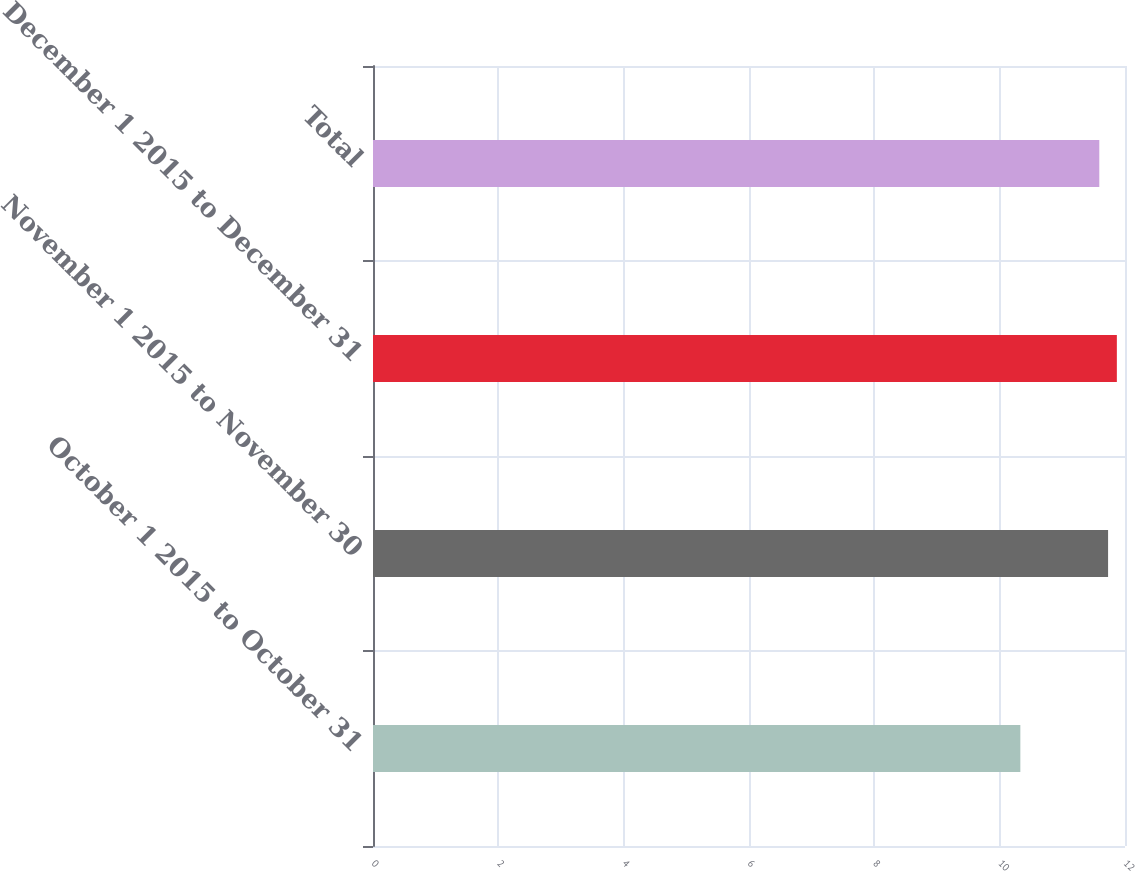<chart> <loc_0><loc_0><loc_500><loc_500><bar_chart><fcel>October 1 2015 to October 31<fcel>November 1 2015 to November 30<fcel>December 1 2015 to December 31<fcel>Total<nl><fcel>10.33<fcel>11.73<fcel>11.87<fcel>11.59<nl></chart> 